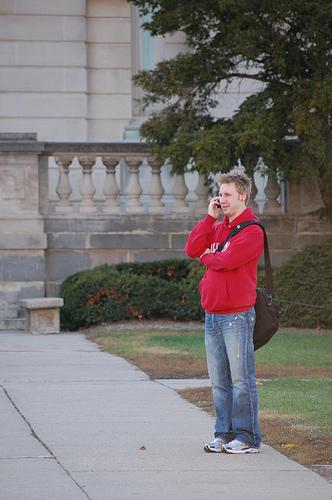What kind of shoes is the person wearing?
Answer briefly. Sneakers. Where is the grass?
Give a very brief answer. Behind man. What is this man wearing on his feet?
Short answer required. Shoes. How many people have luggage?
Short answer required. 1. What is this person standing on?
Write a very short answer. Sidewalk. Is the man a police officer?
Concise answer only. No. What is this child doing?
Keep it brief. Talking on phone. What color is the kids shirt?
Be succinct. Red. Is this person wearing red pants?
Concise answer only. No. Are the people in motion?
Concise answer only. No. What is the red thing in the photo?
Keep it brief. Sweater. Is this man wearing a tie?
Quick response, please. No. What is on the man's right side?
Keep it brief. Bag. What is the man doing?
Short answer required. Talking on phone. Is this man in play clothes?
Keep it brief. Yes. Which hand holds the phone?
Keep it brief. Right. What sports team is he a fan of?
Write a very short answer. Red sox. What is the color of the boys jacket?
Short answer required. Red. Do you think the guy is having a serious phone conversation?
Give a very brief answer. Yes. What color shoes is this person wearing?
Be succinct. White. What sport does this man appear to enjoy?
Short answer required. None. What color are the man's shoes?
Give a very brief answer. White. Is anyone on the bench?
Quick response, please. No. Is this kid running across a street?
Quick response, please. No. What is the man holding?
Give a very brief answer. Phone. Is he on a skateboard?
Be succinct. No. What color is the man's jacket?
Short answer required. Red. How many people on the sidewalk?
Short answer required. 1. Is this person wearing a hat?
Short answer required. No. 